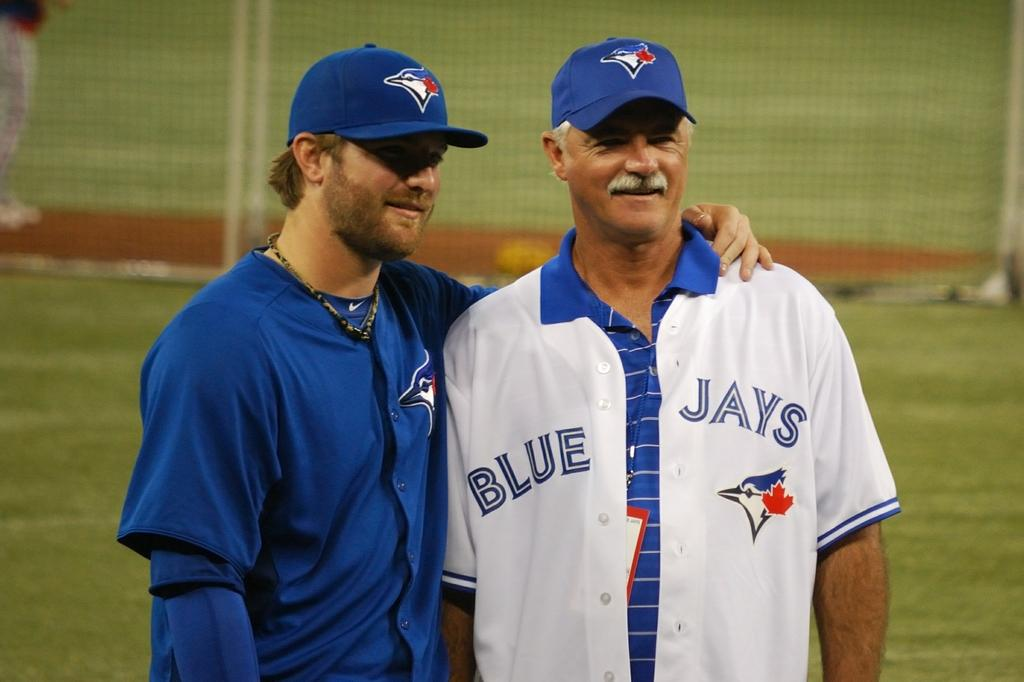<image>
Render a clear and concise summary of the photo. Two men wearing Blue Jay Jerseys stand for a photo. 